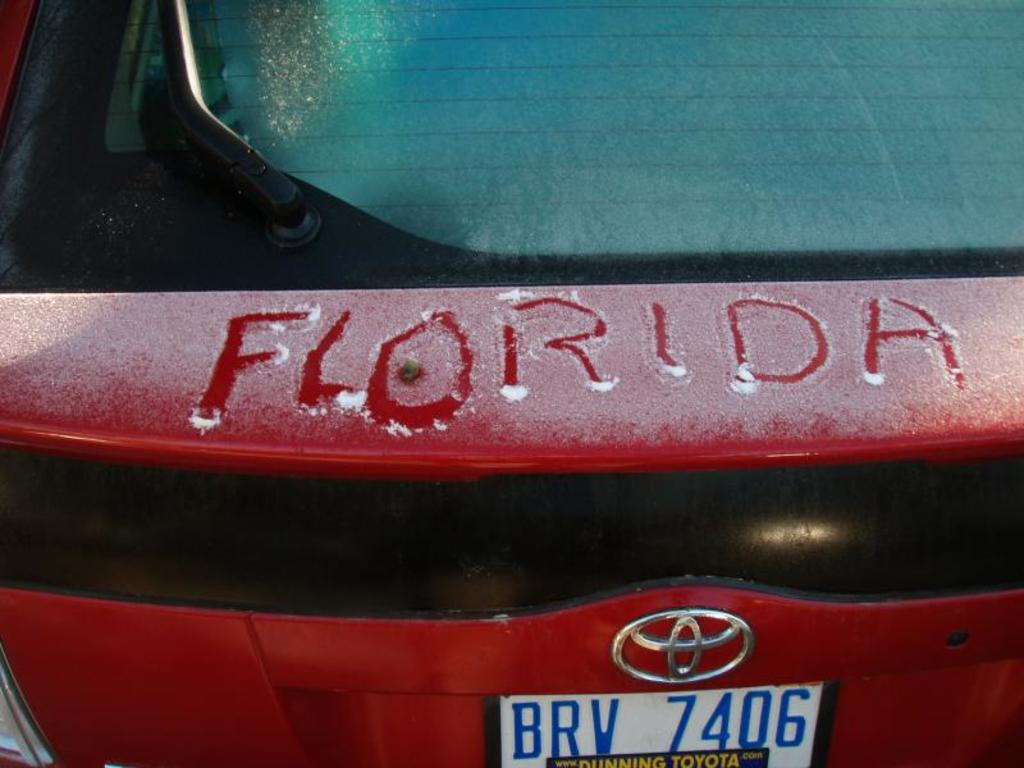Can you tell me about the weather conditions when this photo was taken? The photo depicts cold weather conditions, as indicated by the snow settling on the rear window and trunk of the car. The clear visibility suggests it might be a chilly but sunny morning after a night of light snowfall. 